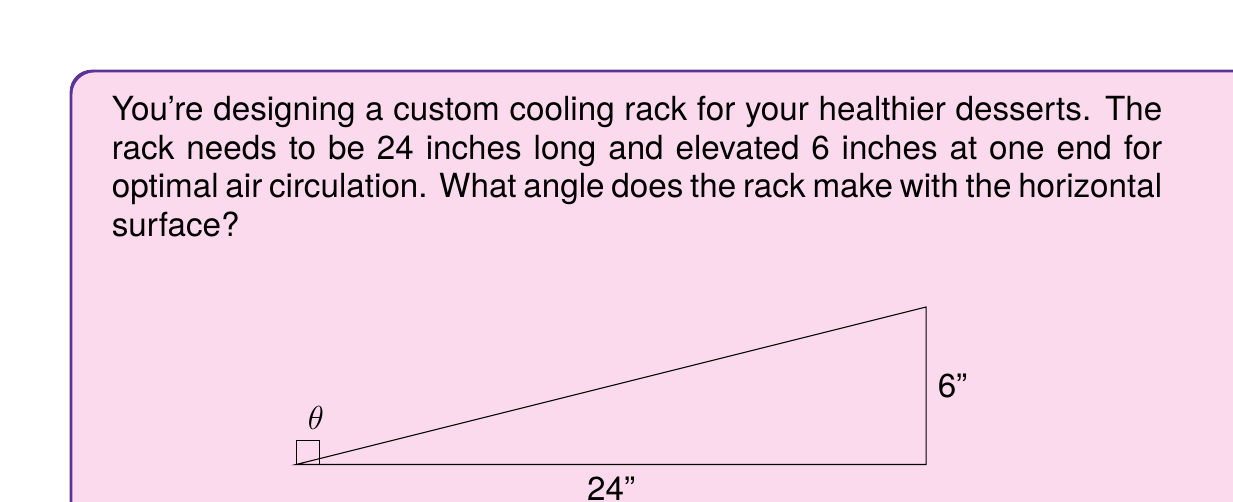Help me with this question. To solve this problem, we can use the basic trigonometric function tangent. The tangent of an angle in a right triangle is the ratio of the opposite side to the adjacent side.

1) In this case, we have a right triangle where:
   - The adjacent side (horizontal distance) is 24 inches
   - The opposite side (vertical height) is 6 inches
   - We need to find the angle $\theta$

2) The tangent of the angle $\theta$ is:

   $$\tan(\theta) = \frac{\text{opposite}}{\text{adjacent}} = \frac{6}{24} = \frac{1}{4} = 0.25$$

3) To find the angle, we need to use the inverse tangent function (also called arctangent or $\tan^{-1}$):

   $$\theta = \tan^{-1}(0.25)$$

4) Using a calculator or trigonometric tables:

   $$\theta \approx 14.04^{\circ}$$

Therefore, the cooling rack makes an angle of approximately 14.04° with the horizontal surface.
Answer: $14.04^{\circ}$ 